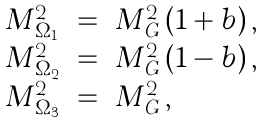<formula> <loc_0><loc_0><loc_500><loc_500>\begin{array} { l c l } M _ { \Omega _ { 1 } } ^ { 2 } & = & M _ { G } ^ { 2 } \, ( 1 + b ) \, , \\ M _ { \Omega _ { 2 } } ^ { 2 } & = & M _ { G } ^ { 2 } \, ( 1 - b ) \, , \\ M _ { \Omega _ { 3 } } ^ { 2 } & = & M _ { G } ^ { 2 } \, , \\ \end{array}</formula> 